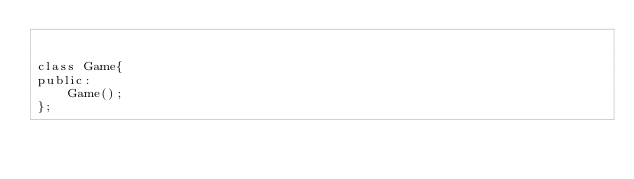Convert code to text. <code><loc_0><loc_0><loc_500><loc_500><_C_>

class Game{
public:
	Game();
};</code> 